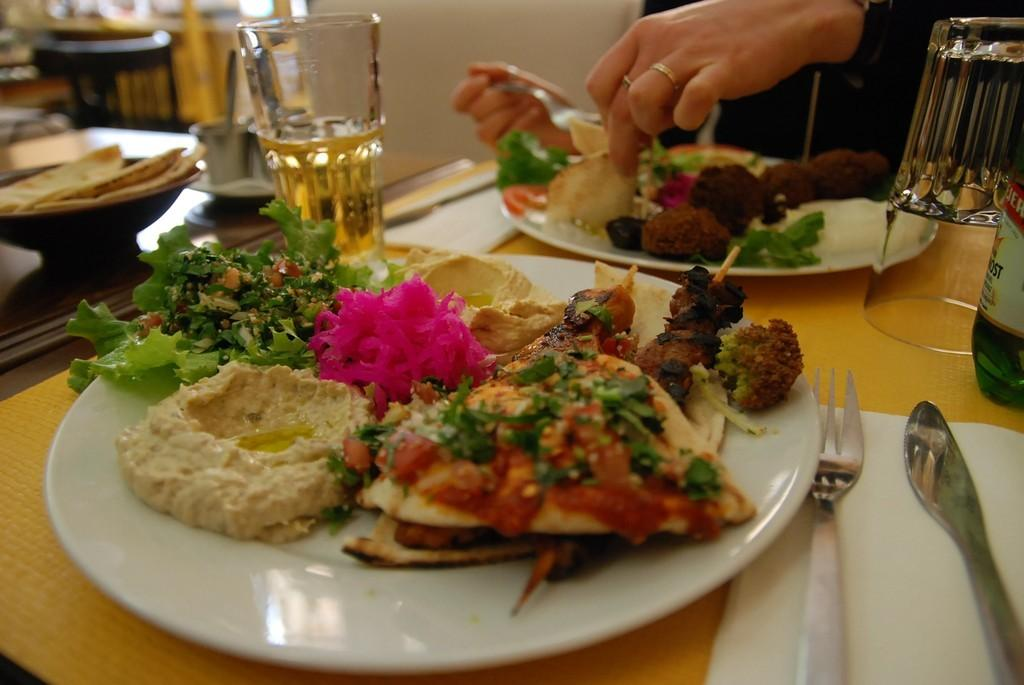What piece of furniture is present in the image? There is a table in the image. What is placed on the table? There are plants on the table. What else can be seen on the table besides plants? There is a food item, glasses, and spoons in the image. What is the man in the image doing? A man is eating food in the image. Where is the kitty hiding in the image? There is no kitty present in the image. What type of vase is holding the flowers on the table? There is no vase mentioned in the image; only plants are described. 